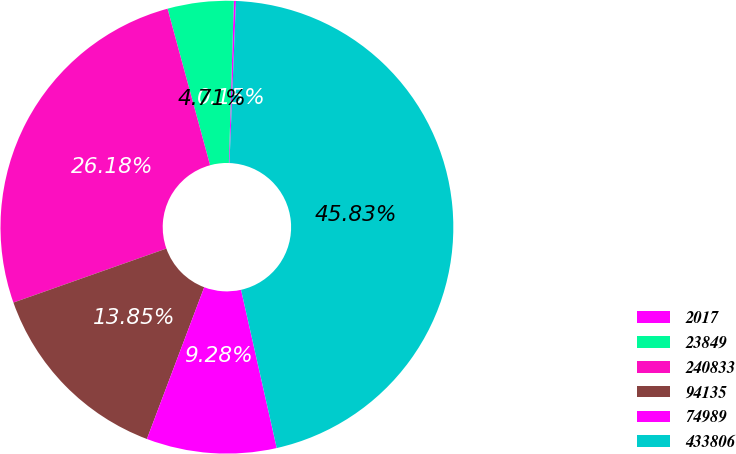Convert chart to OTSL. <chart><loc_0><loc_0><loc_500><loc_500><pie_chart><fcel>2017<fcel>23849<fcel>240833<fcel>94135<fcel>74989<fcel>433806<nl><fcel>0.15%<fcel>4.71%<fcel>26.18%<fcel>13.85%<fcel>9.28%<fcel>45.83%<nl></chart> 